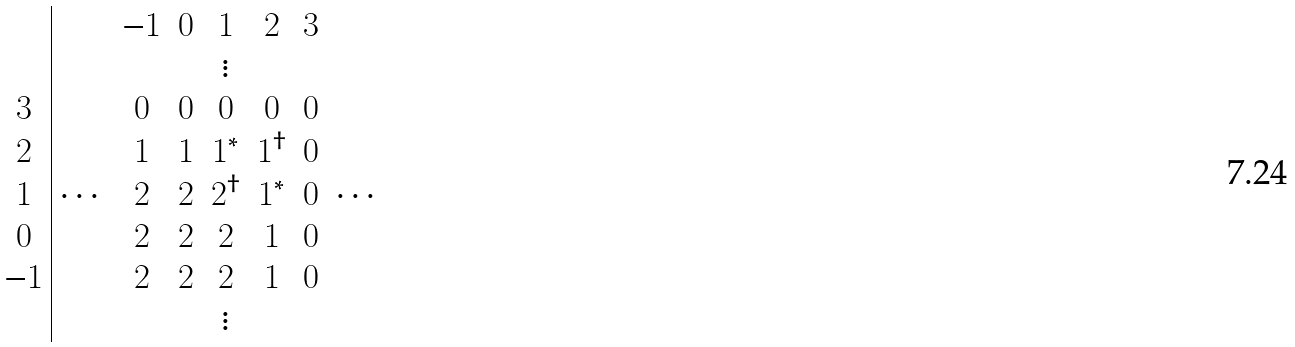Convert formula to latex. <formula><loc_0><loc_0><loc_500><loc_500>\begin{array} { c | c c c c c c c } \, & & - 1 & 0 & 1 & 2 & 3 & \, \\ \, & & & & \vdots & & \, \\ 3 & & 0 & 0 & 0 & 0 & 0 & \, \\ 2 & & 1 & 1 & 1 ^ { * } & 1 ^ { \dagger } & 0 & \, \\ 1 & \cdots & 2 & 2 & 2 ^ { \dagger } & 1 ^ { * } & 0 & \cdots \\ 0 & & 2 & 2 & 2 & 1 & 0 & \, \\ - 1 & & 2 & 2 & 2 & 1 & 0 & \, \\ \, & & & & \vdots & & \, \end{array}</formula> 